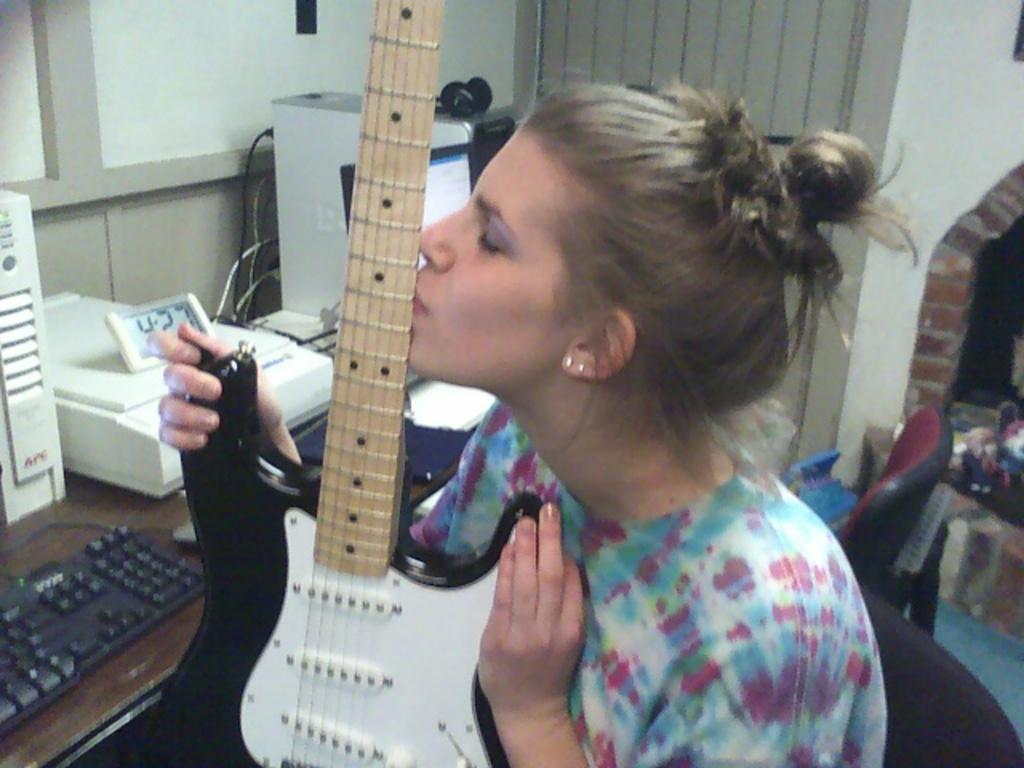Can you describe this image briefly? This image is taken inside a room. In the middle of the image there is a girl sitting on a chair holding a guitar in her hands. In the left side of the image there is a table on which there are few things like keyboard, clock, printer, CPU. In the right side of the image there is an empty chair and a wall and door. 